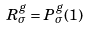Convert formula to latex. <formula><loc_0><loc_0><loc_500><loc_500>R _ { \sigma } ^ { g } = P _ { \sigma } ^ { g } ( 1 )</formula> 